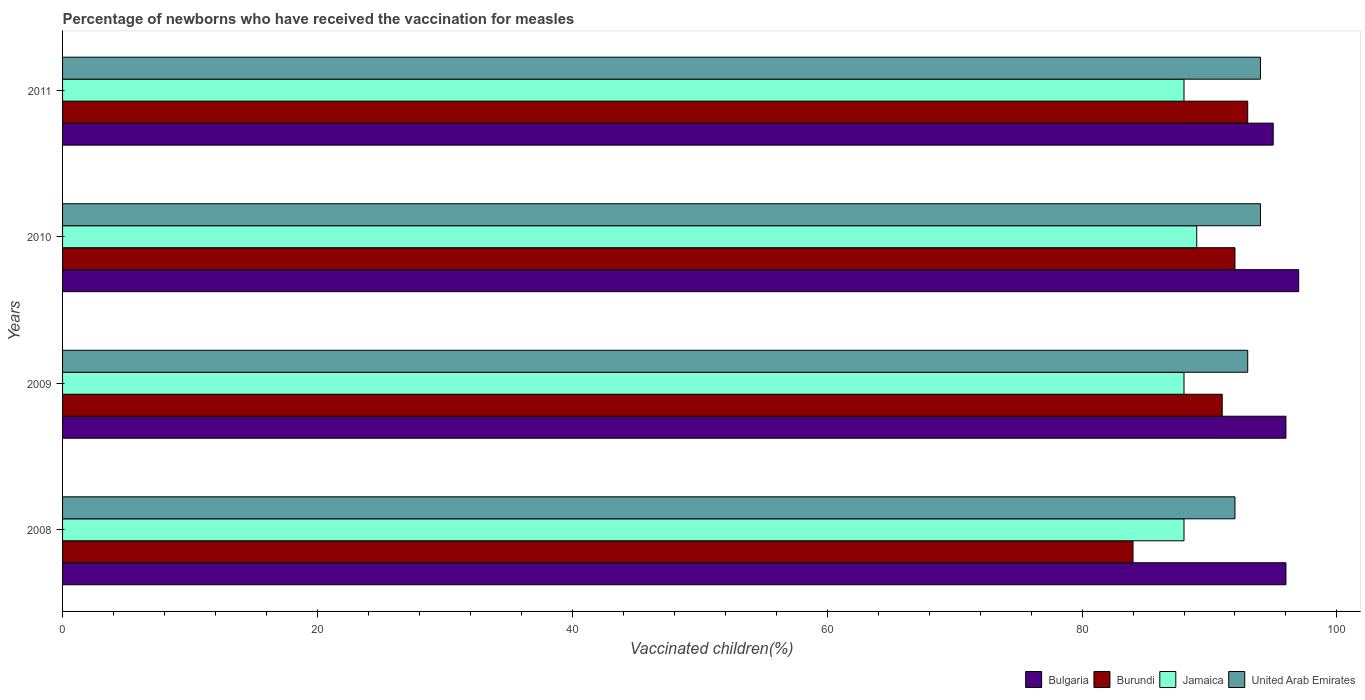How many groups of bars are there?
Give a very brief answer. 4. Are the number of bars on each tick of the Y-axis equal?
Make the answer very short. Yes. How many bars are there on the 4th tick from the top?
Keep it short and to the point. 4. What is the percentage of vaccinated children in United Arab Emirates in 2010?
Offer a very short reply. 94. Across all years, what is the maximum percentage of vaccinated children in United Arab Emirates?
Your response must be concise. 94. Across all years, what is the minimum percentage of vaccinated children in Bulgaria?
Give a very brief answer. 95. What is the total percentage of vaccinated children in Bulgaria in the graph?
Ensure brevity in your answer.  384. What is the difference between the percentage of vaccinated children in Burundi in 2009 and that in 2011?
Give a very brief answer. -2. What is the average percentage of vaccinated children in Jamaica per year?
Keep it short and to the point. 88.25. In the year 2009, what is the difference between the percentage of vaccinated children in Jamaica and percentage of vaccinated children in United Arab Emirates?
Make the answer very short. -5. In how many years, is the percentage of vaccinated children in Jamaica greater than 28 %?
Make the answer very short. 4. What is the ratio of the percentage of vaccinated children in Bulgaria in 2009 to that in 2010?
Your answer should be compact. 0.99. Is the difference between the percentage of vaccinated children in Jamaica in 2009 and 2010 greater than the difference between the percentage of vaccinated children in United Arab Emirates in 2009 and 2010?
Give a very brief answer. No. In how many years, is the percentage of vaccinated children in Jamaica greater than the average percentage of vaccinated children in Jamaica taken over all years?
Make the answer very short. 1. Is the sum of the percentage of vaccinated children in Jamaica in 2009 and 2011 greater than the maximum percentage of vaccinated children in Bulgaria across all years?
Make the answer very short. Yes. What does the 2nd bar from the top in 2008 represents?
Ensure brevity in your answer.  Jamaica. What does the 3rd bar from the bottom in 2008 represents?
Keep it short and to the point. Jamaica. Is it the case that in every year, the sum of the percentage of vaccinated children in Jamaica and percentage of vaccinated children in Bulgaria is greater than the percentage of vaccinated children in Burundi?
Ensure brevity in your answer.  Yes. How many bars are there?
Keep it short and to the point. 16. What is the difference between two consecutive major ticks on the X-axis?
Provide a short and direct response. 20. Does the graph contain any zero values?
Provide a short and direct response. No. How many legend labels are there?
Give a very brief answer. 4. What is the title of the graph?
Give a very brief answer. Percentage of newborns who have received the vaccination for measles. Does "Qatar" appear as one of the legend labels in the graph?
Give a very brief answer. No. What is the label or title of the X-axis?
Your answer should be compact. Vaccinated children(%). What is the Vaccinated children(%) in Bulgaria in 2008?
Offer a terse response. 96. What is the Vaccinated children(%) of Burundi in 2008?
Your answer should be compact. 84. What is the Vaccinated children(%) in Jamaica in 2008?
Provide a short and direct response. 88. What is the Vaccinated children(%) in United Arab Emirates in 2008?
Offer a very short reply. 92. What is the Vaccinated children(%) of Bulgaria in 2009?
Your answer should be compact. 96. What is the Vaccinated children(%) in Burundi in 2009?
Offer a terse response. 91. What is the Vaccinated children(%) in United Arab Emirates in 2009?
Provide a short and direct response. 93. What is the Vaccinated children(%) in Bulgaria in 2010?
Provide a short and direct response. 97. What is the Vaccinated children(%) in Burundi in 2010?
Make the answer very short. 92. What is the Vaccinated children(%) in Jamaica in 2010?
Provide a succinct answer. 89. What is the Vaccinated children(%) in United Arab Emirates in 2010?
Your answer should be compact. 94. What is the Vaccinated children(%) of Bulgaria in 2011?
Your answer should be very brief. 95. What is the Vaccinated children(%) in Burundi in 2011?
Offer a terse response. 93. What is the Vaccinated children(%) in Jamaica in 2011?
Provide a succinct answer. 88. What is the Vaccinated children(%) in United Arab Emirates in 2011?
Keep it short and to the point. 94. Across all years, what is the maximum Vaccinated children(%) of Bulgaria?
Make the answer very short. 97. Across all years, what is the maximum Vaccinated children(%) in Burundi?
Your answer should be very brief. 93. Across all years, what is the maximum Vaccinated children(%) in Jamaica?
Give a very brief answer. 89. Across all years, what is the maximum Vaccinated children(%) in United Arab Emirates?
Give a very brief answer. 94. Across all years, what is the minimum Vaccinated children(%) of United Arab Emirates?
Your answer should be very brief. 92. What is the total Vaccinated children(%) in Bulgaria in the graph?
Your answer should be compact. 384. What is the total Vaccinated children(%) in Burundi in the graph?
Your answer should be very brief. 360. What is the total Vaccinated children(%) of Jamaica in the graph?
Offer a terse response. 353. What is the total Vaccinated children(%) in United Arab Emirates in the graph?
Ensure brevity in your answer.  373. What is the difference between the Vaccinated children(%) of Burundi in 2008 and that in 2009?
Your answer should be very brief. -7. What is the difference between the Vaccinated children(%) in Jamaica in 2008 and that in 2009?
Ensure brevity in your answer.  0. What is the difference between the Vaccinated children(%) of Bulgaria in 2008 and that in 2010?
Your answer should be compact. -1. What is the difference between the Vaccinated children(%) in Jamaica in 2008 and that in 2010?
Ensure brevity in your answer.  -1. What is the difference between the Vaccinated children(%) in Bulgaria in 2008 and that in 2011?
Keep it short and to the point. 1. What is the difference between the Vaccinated children(%) in Jamaica in 2008 and that in 2011?
Your answer should be very brief. 0. What is the difference between the Vaccinated children(%) in United Arab Emirates in 2008 and that in 2011?
Provide a short and direct response. -2. What is the difference between the Vaccinated children(%) of Burundi in 2009 and that in 2010?
Your answer should be very brief. -1. What is the difference between the Vaccinated children(%) of Jamaica in 2009 and that in 2010?
Offer a very short reply. -1. What is the difference between the Vaccinated children(%) in United Arab Emirates in 2009 and that in 2010?
Keep it short and to the point. -1. What is the difference between the Vaccinated children(%) of Bulgaria in 2009 and that in 2011?
Offer a very short reply. 1. What is the difference between the Vaccinated children(%) in Burundi in 2009 and that in 2011?
Your answer should be compact. -2. What is the difference between the Vaccinated children(%) in Jamaica in 2009 and that in 2011?
Your response must be concise. 0. What is the difference between the Vaccinated children(%) of United Arab Emirates in 2009 and that in 2011?
Provide a short and direct response. -1. What is the difference between the Vaccinated children(%) in Burundi in 2010 and that in 2011?
Keep it short and to the point. -1. What is the difference between the Vaccinated children(%) in Bulgaria in 2008 and the Vaccinated children(%) in Burundi in 2009?
Your response must be concise. 5. What is the difference between the Vaccinated children(%) in Bulgaria in 2008 and the Vaccinated children(%) in Jamaica in 2009?
Give a very brief answer. 8. What is the difference between the Vaccinated children(%) of Burundi in 2008 and the Vaccinated children(%) of Jamaica in 2009?
Your answer should be very brief. -4. What is the difference between the Vaccinated children(%) in Burundi in 2008 and the Vaccinated children(%) in United Arab Emirates in 2009?
Provide a succinct answer. -9. What is the difference between the Vaccinated children(%) of Jamaica in 2008 and the Vaccinated children(%) of United Arab Emirates in 2009?
Keep it short and to the point. -5. What is the difference between the Vaccinated children(%) of Bulgaria in 2008 and the Vaccinated children(%) of Burundi in 2010?
Make the answer very short. 4. What is the difference between the Vaccinated children(%) in Bulgaria in 2008 and the Vaccinated children(%) in United Arab Emirates in 2010?
Offer a very short reply. 2. What is the difference between the Vaccinated children(%) of Burundi in 2008 and the Vaccinated children(%) of Jamaica in 2010?
Provide a short and direct response. -5. What is the difference between the Vaccinated children(%) in Burundi in 2008 and the Vaccinated children(%) in United Arab Emirates in 2010?
Give a very brief answer. -10. What is the difference between the Vaccinated children(%) in Jamaica in 2008 and the Vaccinated children(%) in United Arab Emirates in 2010?
Give a very brief answer. -6. What is the difference between the Vaccinated children(%) of Bulgaria in 2008 and the Vaccinated children(%) of Burundi in 2011?
Your answer should be very brief. 3. What is the difference between the Vaccinated children(%) of Bulgaria in 2008 and the Vaccinated children(%) of Jamaica in 2011?
Provide a succinct answer. 8. What is the difference between the Vaccinated children(%) of Bulgaria in 2008 and the Vaccinated children(%) of United Arab Emirates in 2011?
Your answer should be very brief. 2. What is the difference between the Vaccinated children(%) in Bulgaria in 2009 and the Vaccinated children(%) in United Arab Emirates in 2010?
Your answer should be very brief. 2. What is the difference between the Vaccinated children(%) of Burundi in 2009 and the Vaccinated children(%) of United Arab Emirates in 2010?
Keep it short and to the point. -3. What is the difference between the Vaccinated children(%) of Bulgaria in 2009 and the Vaccinated children(%) of Burundi in 2011?
Provide a succinct answer. 3. What is the difference between the Vaccinated children(%) of Burundi in 2009 and the Vaccinated children(%) of Jamaica in 2011?
Ensure brevity in your answer.  3. What is the difference between the Vaccinated children(%) of Jamaica in 2009 and the Vaccinated children(%) of United Arab Emirates in 2011?
Your response must be concise. -6. What is the difference between the Vaccinated children(%) of Bulgaria in 2010 and the Vaccinated children(%) of Burundi in 2011?
Provide a succinct answer. 4. What is the difference between the Vaccinated children(%) of Bulgaria in 2010 and the Vaccinated children(%) of Jamaica in 2011?
Give a very brief answer. 9. What is the difference between the Vaccinated children(%) in Bulgaria in 2010 and the Vaccinated children(%) in United Arab Emirates in 2011?
Give a very brief answer. 3. What is the difference between the Vaccinated children(%) of Burundi in 2010 and the Vaccinated children(%) of United Arab Emirates in 2011?
Make the answer very short. -2. What is the average Vaccinated children(%) in Bulgaria per year?
Offer a very short reply. 96. What is the average Vaccinated children(%) in Jamaica per year?
Offer a terse response. 88.25. What is the average Vaccinated children(%) of United Arab Emirates per year?
Your answer should be compact. 93.25. In the year 2008, what is the difference between the Vaccinated children(%) in Bulgaria and Vaccinated children(%) in Burundi?
Offer a very short reply. 12. In the year 2008, what is the difference between the Vaccinated children(%) in Bulgaria and Vaccinated children(%) in Jamaica?
Ensure brevity in your answer.  8. In the year 2008, what is the difference between the Vaccinated children(%) in Bulgaria and Vaccinated children(%) in United Arab Emirates?
Give a very brief answer. 4. In the year 2008, what is the difference between the Vaccinated children(%) in Burundi and Vaccinated children(%) in Jamaica?
Provide a short and direct response. -4. In the year 2009, what is the difference between the Vaccinated children(%) in Bulgaria and Vaccinated children(%) in Burundi?
Your answer should be compact. 5. In the year 2009, what is the difference between the Vaccinated children(%) in Bulgaria and Vaccinated children(%) in United Arab Emirates?
Provide a succinct answer. 3. In the year 2009, what is the difference between the Vaccinated children(%) of Burundi and Vaccinated children(%) of Jamaica?
Provide a succinct answer. 3. In the year 2009, what is the difference between the Vaccinated children(%) in Burundi and Vaccinated children(%) in United Arab Emirates?
Your answer should be very brief. -2. In the year 2010, what is the difference between the Vaccinated children(%) of Bulgaria and Vaccinated children(%) of United Arab Emirates?
Make the answer very short. 3. In the year 2010, what is the difference between the Vaccinated children(%) of Burundi and Vaccinated children(%) of United Arab Emirates?
Make the answer very short. -2. In the year 2011, what is the difference between the Vaccinated children(%) of Bulgaria and Vaccinated children(%) of Burundi?
Provide a short and direct response. 2. In the year 2011, what is the difference between the Vaccinated children(%) in Bulgaria and Vaccinated children(%) in United Arab Emirates?
Ensure brevity in your answer.  1. In the year 2011, what is the difference between the Vaccinated children(%) in Burundi and Vaccinated children(%) in United Arab Emirates?
Offer a terse response. -1. What is the ratio of the Vaccinated children(%) of Burundi in 2008 to that in 2010?
Make the answer very short. 0.91. What is the ratio of the Vaccinated children(%) in Jamaica in 2008 to that in 2010?
Offer a very short reply. 0.99. What is the ratio of the Vaccinated children(%) of United Arab Emirates in 2008 to that in 2010?
Offer a very short reply. 0.98. What is the ratio of the Vaccinated children(%) in Bulgaria in 2008 to that in 2011?
Keep it short and to the point. 1.01. What is the ratio of the Vaccinated children(%) of Burundi in 2008 to that in 2011?
Your answer should be very brief. 0.9. What is the ratio of the Vaccinated children(%) in United Arab Emirates in 2008 to that in 2011?
Keep it short and to the point. 0.98. What is the ratio of the Vaccinated children(%) in Burundi in 2009 to that in 2010?
Ensure brevity in your answer.  0.99. What is the ratio of the Vaccinated children(%) in Jamaica in 2009 to that in 2010?
Make the answer very short. 0.99. What is the ratio of the Vaccinated children(%) of United Arab Emirates in 2009 to that in 2010?
Your answer should be very brief. 0.99. What is the ratio of the Vaccinated children(%) of Bulgaria in 2009 to that in 2011?
Provide a short and direct response. 1.01. What is the ratio of the Vaccinated children(%) in Burundi in 2009 to that in 2011?
Your response must be concise. 0.98. What is the ratio of the Vaccinated children(%) of Jamaica in 2009 to that in 2011?
Your response must be concise. 1. What is the ratio of the Vaccinated children(%) of Bulgaria in 2010 to that in 2011?
Provide a succinct answer. 1.02. What is the ratio of the Vaccinated children(%) in Jamaica in 2010 to that in 2011?
Offer a terse response. 1.01. What is the difference between the highest and the second highest Vaccinated children(%) in Bulgaria?
Your response must be concise. 1. What is the difference between the highest and the second highest Vaccinated children(%) of Jamaica?
Your answer should be very brief. 1. What is the difference between the highest and the second highest Vaccinated children(%) in United Arab Emirates?
Offer a terse response. 0. What is the difference between the highest and the lowest Vaccinated children(%) of Bulgaria?
Make the answer very short. 2. What is the difference between the highest and the lowest Vaccinated children(%) of Burundi?
Provide a short and direct response. 9. What is the difference between the highest and the lowest Vaccinated children(%) in Jamaica?
Give a very brief answer. 1. What is the difference between the highest and the lowest Vaccinated children(%) of United Arab Emirates?
Make the answer very short. 2. 